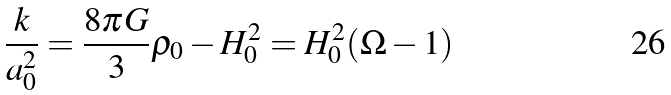Convert formula to latex. <formula><loc_0><loc_0><loc_500><loc_500>\frac { k } { a _ { 0 } ^ { 2 } } = \frac { 8 \pi G } { 3 } \rho _ { 0 } - H _ { 0 } ^ { 2 } = H _ { 0 } ^ { 2 } ( \Omega - 1 )</formula> 